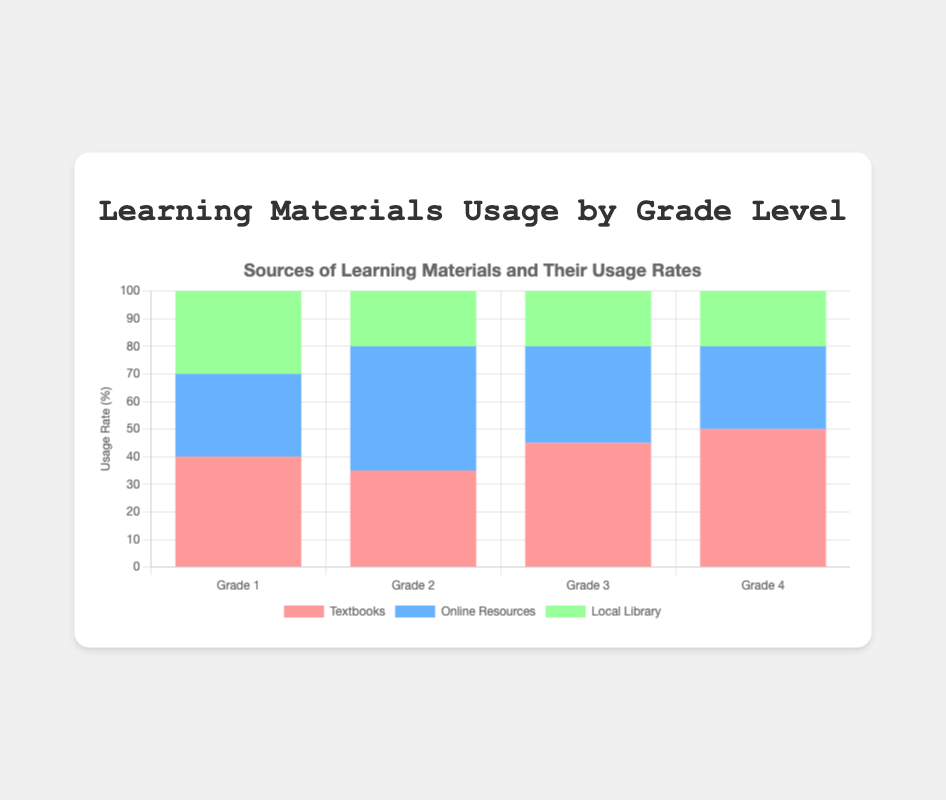What's the most used learning material for Grade 4? The bar for "Textbooks" in Grade 4 is the tallest compared to other sources ("Online Resources" and "Local Library").
Answer: Textbooks Which class level has the highest usage rate for online resources? The blue bar representing "Online Resources" is the tallest in "Grade 2" compared to other class levels.
Answer: Grade 2 How much more are textbooks used in Grade 3 compared to online resources in Grade 3? The bar for textbooks in Grade 3 is at 45%, and the bar for online resources in Grade 3 is at 35%. So, 45% - 35% = 10%.
Answer: 10% For which grade level is the usage rate of local library the same? The green bar for "Local Library" is at the same height (20%) for Grade 2, Grade 3, and Grade 4.
Answer: Grade 2, Grade 3, Grade 4 What's the difference in the usage rate of textbooks between Grade 1 and Grade 4? The bar for textbooks in Grade 1 is at 40%, while in Grade 4 it is 50%. Thus, the difference is 50% - 40% = 10%.
Answer: 10% What is the total usage rate of all sources for Grade 1? For Grade 1, add the usage rates: Textbooks (40%) + Online Resources (30%) + Local Library (30%) = 100%.
Answer: 100% Which grade level has the lowest usage rate for local library? The height of the green bars for "Local Library" is the same for Grades 2, 3, and 4 at 20%, but for Grade 1, the height is 30%. The lowest is 20%.
Answer: Grade 2, Grade 3, Grade 4 Compare the total usage rate of online resources and local library in Grade 2. Which one is higher? For Grade 2, Online Resources is 45% and Local Library is 20%. Online Resources is higher.
Answer: Online Resources What is the average usage rate of textbooks across all grades? Average usage rate for textbooks: (40% + 35% + 45% + 50%) / 4 = 170% / 4 = 42.5%.
Answer: 42.5% What's the overall usage rate of online resources in Grade 4 compared to Grade 1? In Grade 4, the usage rate of online resources is 30%, while in Grade 1, it is also 30%. So, they are equal.
Answer: Equal 